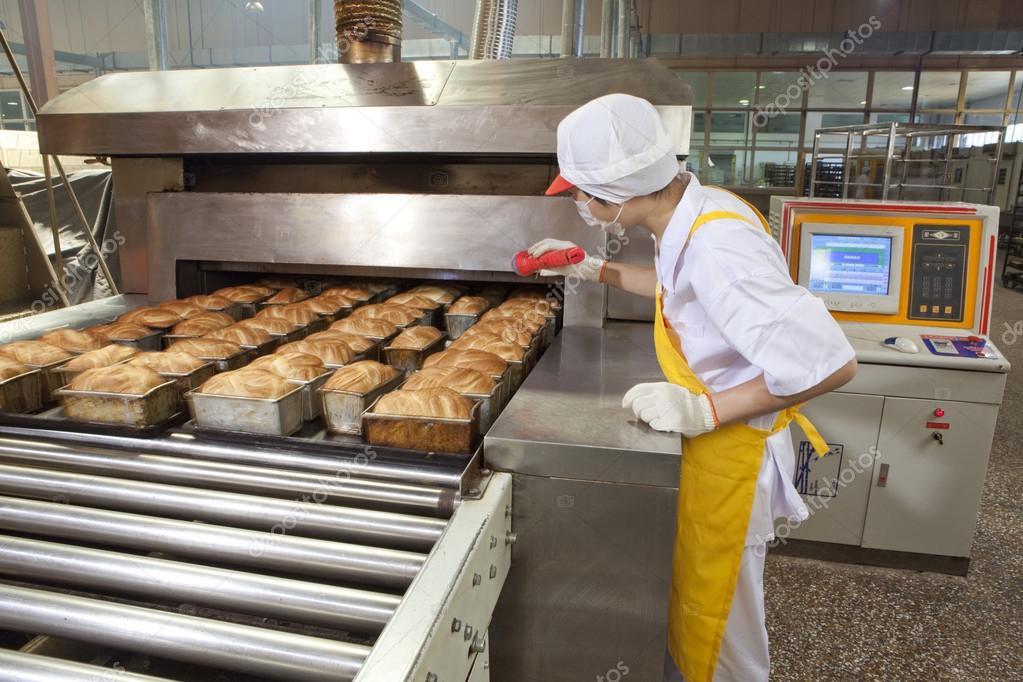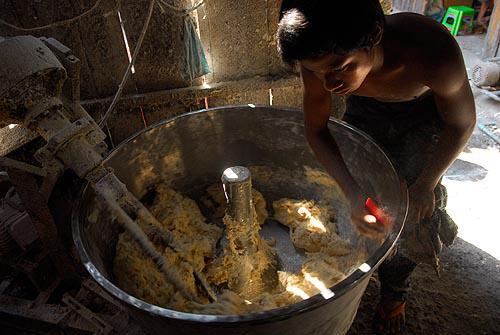The first image is the image on the left, the second image is the image on the right. Examine the images to the left and right. Is the description "A baker in a white shirt and hat works in the kitchen in one of the images." accurate? Answer yes or no. Yes. The first image is the image on the left, the second image is the image on the right. Examine the images to the left and right. Is the description "The right image shows a smiling man in a white shirt bending forward by racks of bread." accurate? Answer yes or no. No. 